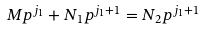Convert formula to latex. <formula><loc_0><loc_0><loc_500><loc_500>M p ^ { j _ { 1 } } + N _ { 1 } p ^ { j _ { 1 } + 1 } = N _ { 2 } p ^ { j _ { 1 } + 1 }</formula> 